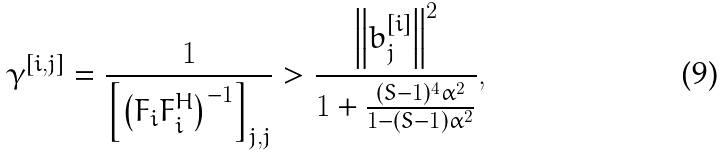Convert formula to latex. <formula><loc_0><loc_0><loc_500><loc_500>\gamma ^ { [ i , j ] } & = \frac { 1 } { \left [ \left ( F _ { i } F _ { i } ^ { H } \right ) ^ { - 1 } \right ] _ { j , j } } > \frac { \left \| b _ { j } ^ { [ i ] } \right \| ^ { 2 } } { 1 + \frac { ( S - 1 ) ^ { 4 } \alpha ^ { 2 } } { 1 - ( S - 1 ) \alpha ^ { 2 } } } ,</formula> 